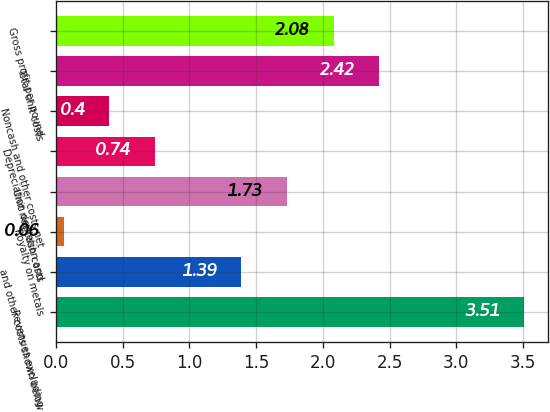<chart> <loc_0><loc_0><loc_500><loc_500><bar_chart><fcel>Revenues excluding<fcel>and other costs shown below<fcel>Royalty on metals<fcel>Unit net cash costs<fcel>Depreciation depletion and<fcel>Noncash and other costs net<fcel>Total unit costs<fcel>Gross profit per pound<nl><fcel>3.51<fcel>1.39<fcel>0.06<fcel>1.73<fcel>0.74<fcel>0.4<fcel>2.42<fcel>2.08<nl></chart> 